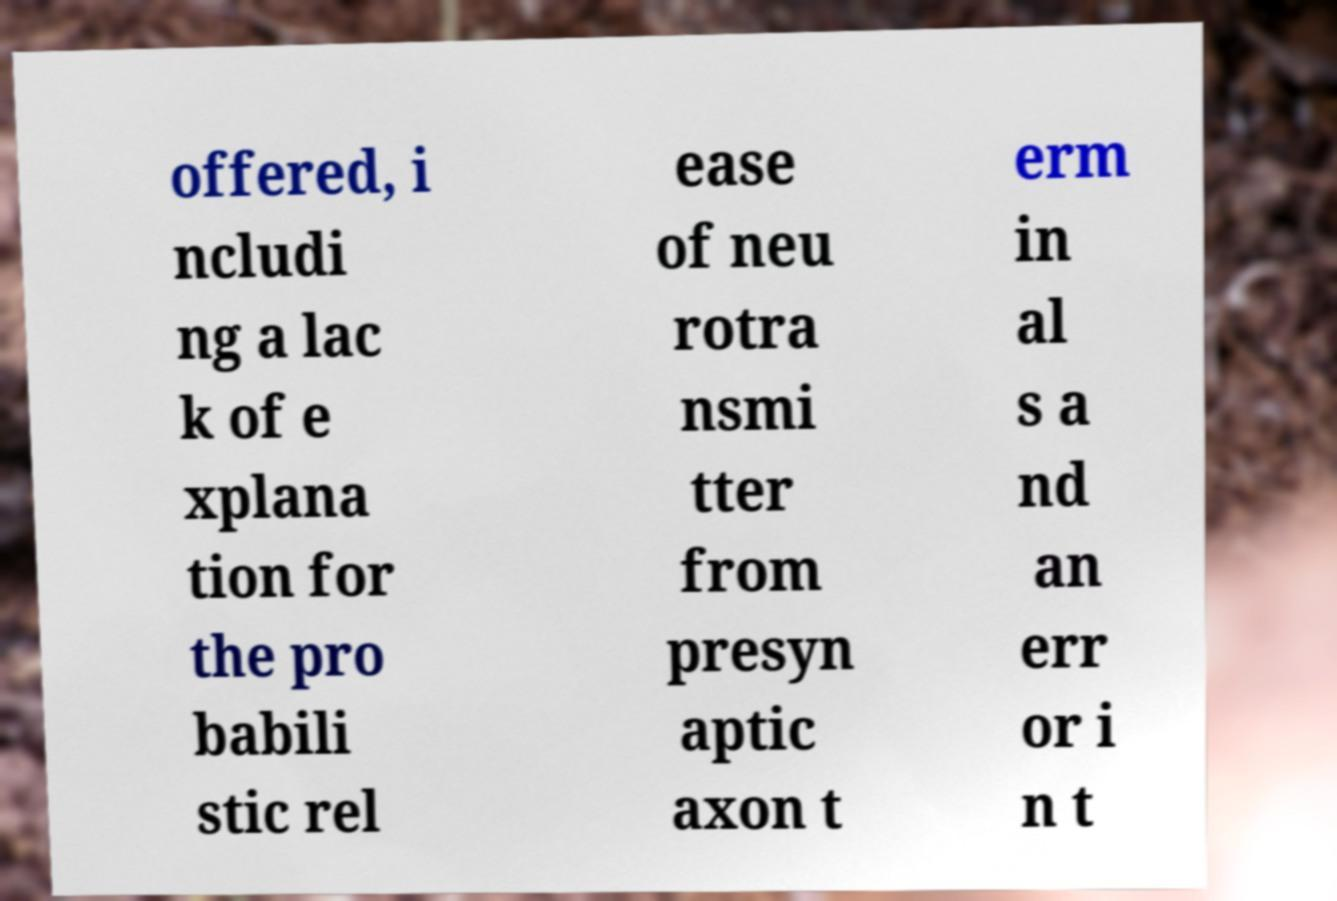What messages or text are displayed in this image? I need them in a readable, typed format. offered, i ncludi ng a lac k of e xplana tion for the pro babili stic rel ease of neu rotra nsmi tter from presyn aptic axon t erm in al s a nd an err or i n t 